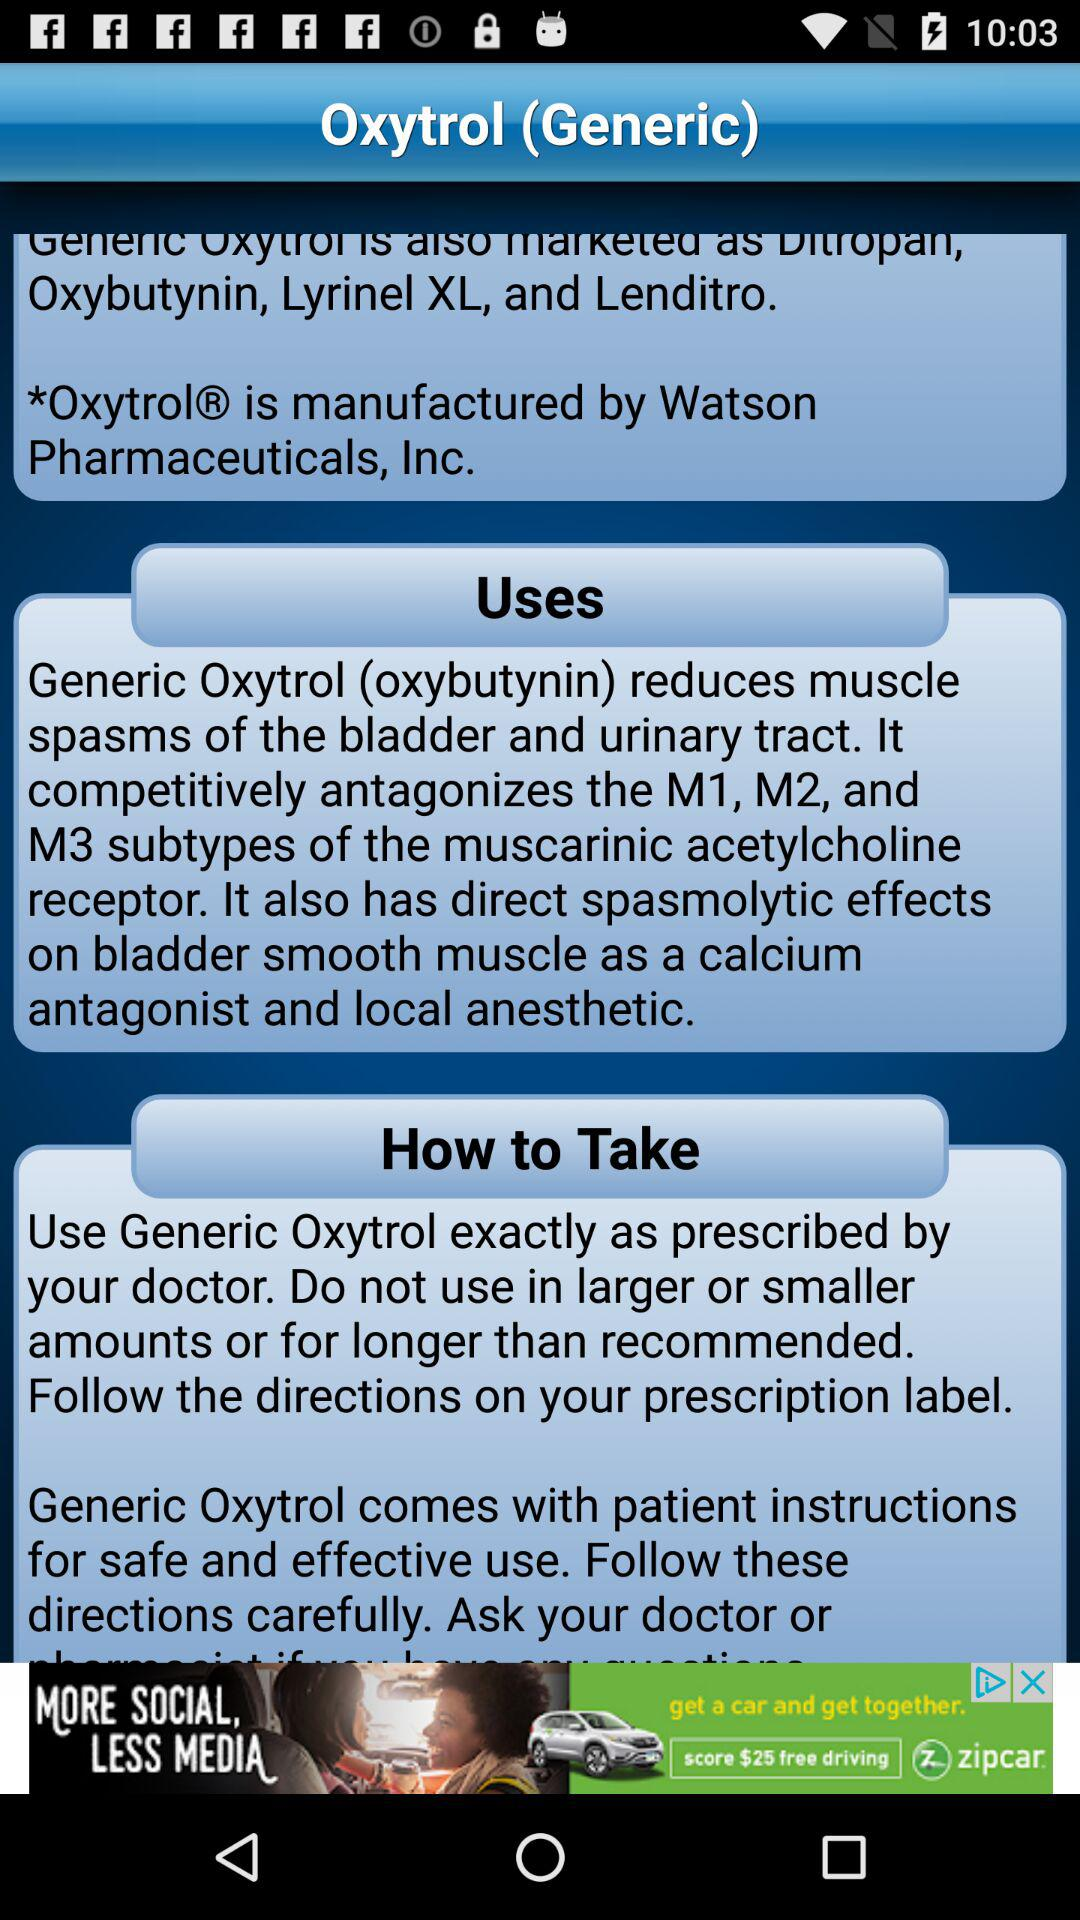What are the uses of Oxytrol? The uses of Oxytrol are: " Generic Oxytrol (oxybutynin) reduces muscle spasms of the bladder and urinary tract. It competitively antagonizes the M1, M2, and M3 subtypes of the muscarinic acetylcholine receptor. It also has direct spasmolytic effects on bladder smooth muscle as a calcium antagonist and local anesthetic.". 